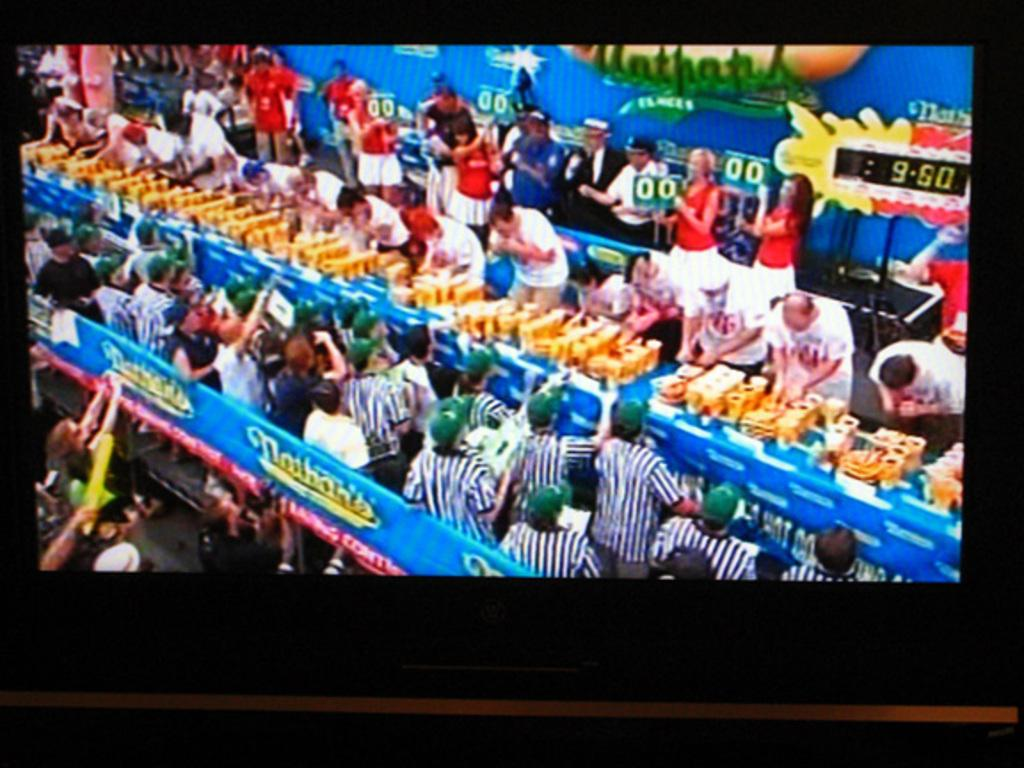<image>
Create a compact narrative representing the image presented. a crowd of people shopping at the Nathans market 